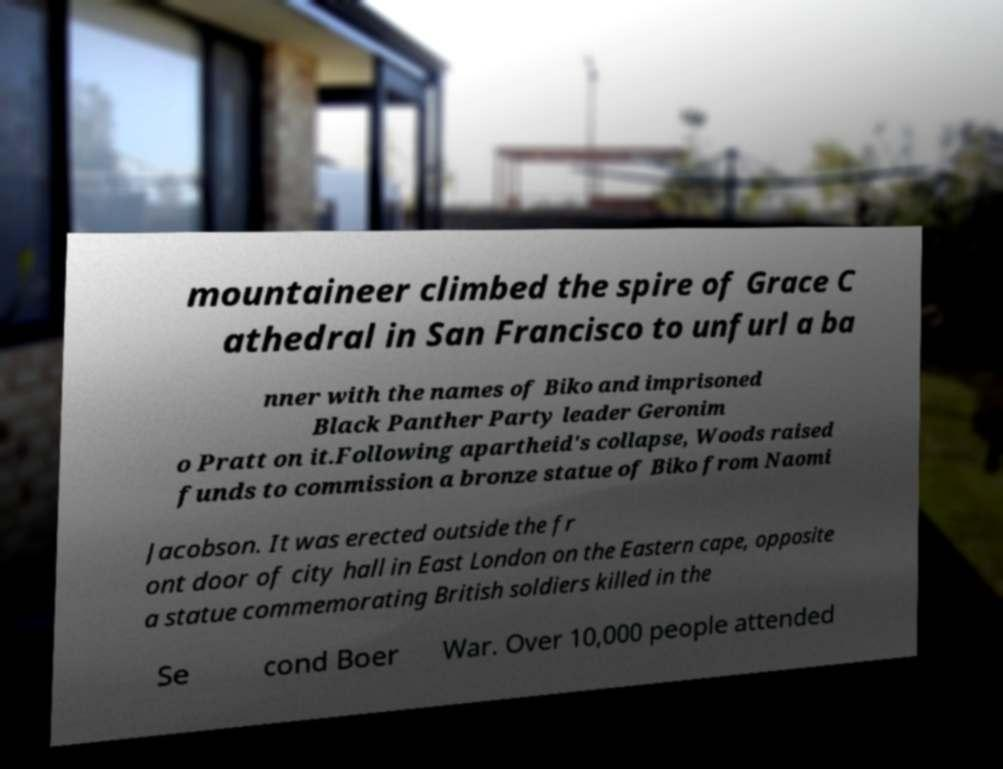Could you extract and type out the text from this image? mountaineer climbed the spire of Grace C athedral in San Francisco to unfurl a ba nner with the names of Biko and imprisoned Black Panther Party leader Geronim o Pratt on it.Following apartheid's collapse, Woods raised funds to commission a bronze statue of Biko from Naomi Jacobson. It was erected outside the fr ont door of city hall in East London on the Eastern cape, opposite a statue commemorating British soldiers killed in the Se cond Boer War. Over 10,000 people attended 